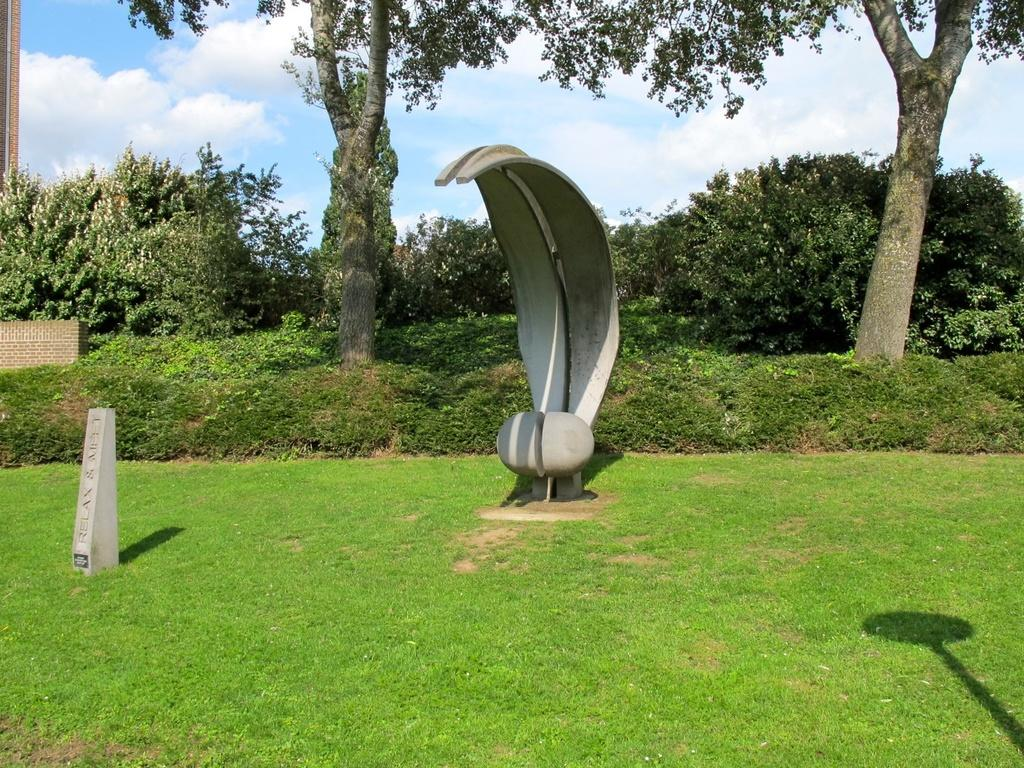What type of outdoor area is depicted in the image? There is a garden in the image. What can be found in the garden? There is a stone and a sculpture in the garden. What is visible in the background of the image? There are plants and trees in the background of the image. Can you describe the hat that the beetle is wearing in the image? There is no beetle or hat mentioned in the image. The image describes a garden with a stone and a sculpture, along with plants and trees in the background. 